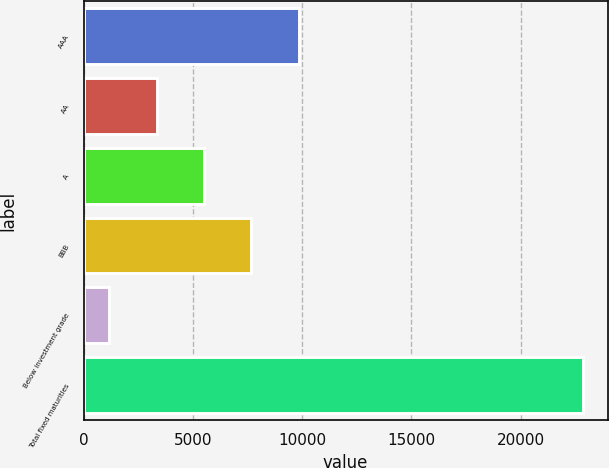Convert chart. <chart><loc_0><loc_0><loc_500><loc_500><bar_chart><fcel>AAA<fcel>AA<fcel>A<fcel>BBB<fcel>Below investment grade<fcel>Total fixed maturities<nl><fcel>9838.8<fcel>3340.2<fcel>5506.4<fcel>7672.6<fcel>1174<fcel>22836<nl></chart> 